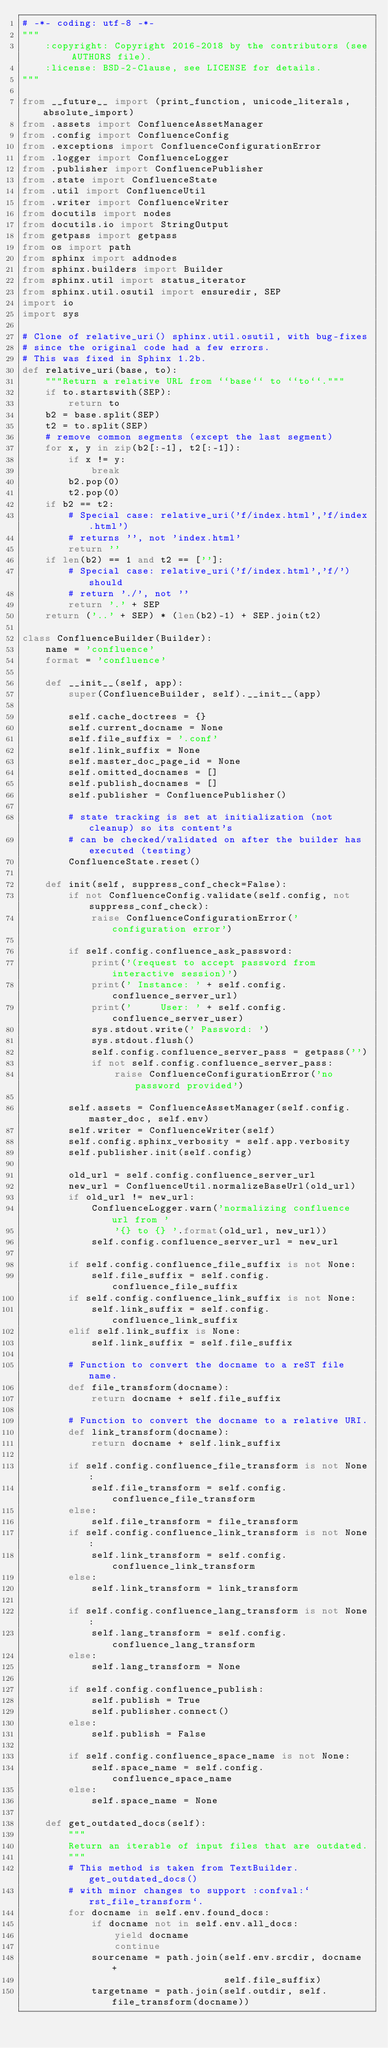Convert code to text. <code><loc_0><loc_0><loc_500><loc_500><_Python_># -*- coding: utf-8 -*-
"""
    :copyright: Copyright 2016-2018 by the contributors (see AUTHORS file).
    :license: BSD-2-Clause, see LICENSE for details.
"""

from __future__ import (print_function, unicode_literals, absolute_import)
from .assets import ConfluenceAssetManager
from .config import ConfluenceConfig
from .exceptions import ConfluenceConfigurationError
from .logger import ConfluenceLogger
from .publisher import ConfluencePublisher
from .state import ConfluenceState
from .util import ConfluenceUtil
from .writer import ConfluenceWriter
from docutils import nodes
from docutils.io import StringOutput
from getpass import getpass
from os import path
from sphinx import addnodes
from sphinx.builders import Builder
from sphinx.util import status_iterator
from sphinx.util.osutil import ensuredir, SEP
import io
import sys

# Clone of relative_uri() sphinx.util.osutil, with bug-fixes
# since the original code had a few errors.
# This was fixed in Sphinx 1.2b.
def relative_uri(base, to):
    """Return a relative URL from ``base`` to ``to``."""
    if to.startswith(SEP):
        return to
    b2 = base.split(SEP)
    t2 = to.split(SEP)
    # remove common segments (except the last segment)
    for x, y in zip(b2[:-1], t2[:-1]):
        if x != y:
            break
        b2.pop(0)
        t2.pop(0)
    if b2 == t2:
        # Special case: relative_uri('f/index.html','f/index.html')
        # returns '', not 'index.html'
        return ''
    if len(b2) == 1 and t2 == ['']:
        # Special case: relative_uri('f/index.html','f/') should
        # return './', not ''
        return '.' + SEP
    return ('..' + SEP) * (len(b2)-1) + SEP.join(t2)

class ConfluenceBuilder(Builder):
    name = 'confluence'
    format = 'confluence'

    def __init__(self, app):
        super(ConfluenceBuilder, self).__init__(app)

        self.cache_doctrees = {}
        self.current_docname = None
        self.file_suffix = '.conf'
        self.link_suffix = None
        self.master_doc_page_id = None
        self.omitted_docnames = []
        self.publish_docnames = []
        self.publisher = ConfluencePublisher()

        # state tracking is set at initialization (not cleanup) so its content's
        # can be checked/validated on after the builder has executed (testing)
        ConfluenceState.reset()

    def init(self, suppress_conf_check=False):
        if not ConfluenceConfig.validate(self.config, not suppress_conf_check):
            raise ConfluenceConfigurationError('configuration error')

        if self.config.confluence_ask_password:
            print('(request to accept password from interactive session)')
            print(' Instance: ' + self.config.confluence_server_url)
            print('     User: ' + self.config.confluence_server_user)
            sys.stdout.write(' Password: ')
            sys.stdout.flush()
            self.config.confluence_server_pass = getpass('')
            if not self.config.confluence_server_pass:
                raise ConfluenceConfigurationError('no password provided')

        self.assets = ConfluenceAssetManager(self.config.master_doc, self.env)
        self.writer = ConfluenceWriter(self)
        self.config.sphinx_verbosity = self.app.verbosity
        self.publisher.init(self.config)

        old_url = self.config.confluence_server_url
        new_url = ConfluenceUtil.normalizeBaseUrl(old_url)
        if old_url != new_url:
            ConfluenceLogger.warn('normalizing confluence url from '
                '{} to {} '.format(old_url, new_url))
            self.config.confluence_server_url = new_url

        if self.config.confluence_file_suffix is not None:
            self.file_suffix = self.config.confluence_file_suffix
        if self.config.confluence_link_suffix is not None:
            self.link_suffix = self.config.confluence_link_suffix
        elif self.link_suffix is None:
            self.link_suffix = self.file_suffix

        # Function to convert the docname to a reST file name.
        def file_transform(docname):
            return docname + self.file_suffix

        # Function to convert the docname to a relative URI.
        def link_transform(docname):
            return docname + self.link_suffix

        if self.config.confluence_file_transform is not None:
            self.file_transform = self.config.confluence_file_transform
        else:
            self.file_transform = file_transform
        if self.config.confluence_link_transform is not None:
            self.link_transform = self.config.confluence_link_transform
        else:
            self.link_transform = link_transform

        if self.config.confluence_lang_transform is not None:
            self.lang_transform = self.config.confluence_lang_transform
        else:
            self.lang_transform = None

        if self.config.confluence_publish:
            self.publish = True
            self.publisher.connect()
        else:
            self.publish = False

        if self.config.confluence_space_name is not None:
            self.space_name = self.config.confluence_space_name
        else:
            self.space_name = None

    def get_outdated_docs(self):
        """
        Return an iterable of input files that are outdated.
        """
        # This method is taken from TextBuilder.get_outdated_docs()
        # with minor changes to support :confval:`rst_file_transform`.
        for docname in self.env.found_docs:
            if docname not in self.env.all_docs:
                yield docname
                continue
            sourcename = path.join(self.env.srcdir, docname +
                                   self.file_suffix)
            targetname = path.join(self.outdir, self.file_transform(docname))</code> 